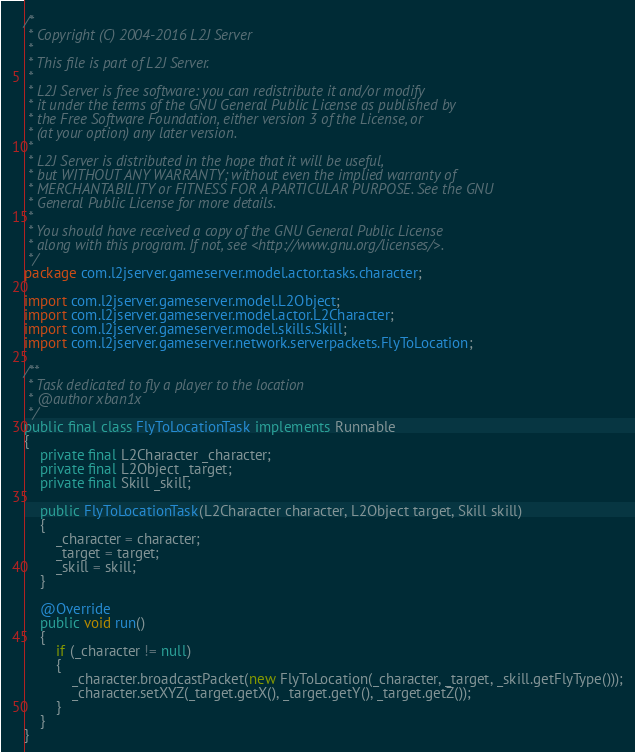Convert code to text. <code><loc_0><loc_0><loc_500><loc_500><_Java_>/*
 * Copyright (C) 2004-2016 L2J Server
 * 
 * This file is part of L2J Server.
 * 
 * L2J Server is free software: you can redistribute it and/or modify
 * it under the terms of the GNU General Public License as published by
 * the Free Software Foundation, either version 3 of the License, or
 * (at your option) any later version.
 * 
 * L2J Server is distributed in the hope that it will be useful,
 * but WITHOUT ANY WARRANTY; without even the implied warranty of
 * MERCHANTABILITY or FITNESS FOR A PARTICULAR PURPOSE. See the GNU
 * General Public License for more details.
 * 
 * You should have received a copy of the GNU General Public License
 * along with this program. If not, see <http://www.gnu.org/licenses/>.
 */
package com.l2jserver.gameserver.model.actor.tasks.character;

import com.l2jserver.gameserver.model.L2Object;
import com.l2jserver.gameserver.model.actor.L2Character;
import com.l2jserver.gameserver.model.skills.Skill;
import com.l2jserver.gameserver.network.serverpackets.FlyToLocation;

/**
 * Task dedicated to fly a player to the location
 * @author xban1x
 */
public final class FlyToLocationTask implements Runnable
{
	private final L2Character _character;
	private final L2Object _target;
	private final Skill _skill;
	
	public FlyToLocationTask(L2Character character, L2Object target, Skill skill)
	{
		_character = character;
		_target = target;
		_skill = skill;
	}
	
	@Override
	public void run()
	{
		if (_character != null)
		{
			_character.broadcastPacket(new FlyToLocation(_character, _target, _skill.getFlyType()));
			_character.setXYZ(_target.getX(), _target.getY(), _target.getZ());
		}
	}
}
</code> 